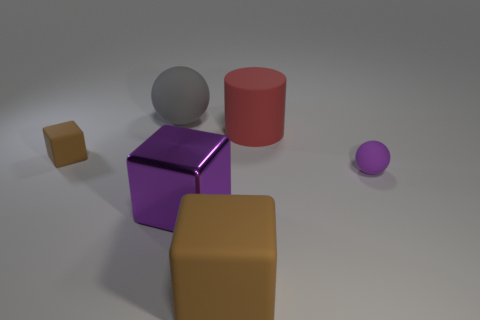Is there any other thing that is made of the same material as the large purple thing?
Keep it short and to the point. No. Is the size of the brown matte block in front of the purple rubber thing the same as the tiny purple rubber object?
Your answer should be very brief. No. Is the number of large matte cubes less than the number of tiny purple metallic cylinders?
Offer a very short reply. No. The tiny object that is in front of the brown thing that is to the left of the rubber sphere left of the red cylinder is what shape?
Give a very brief answer. Sphere. Is there a big purple thing made of the same material as the big brown block?
Your answer should be very brief. No. Does the rubber ball on the right side of the red rubber cylinder have the same color as the metallic cube that is on the right side of the gray matte thing?
Ensure brevity in your answer.  Yes. Is the number of large gray matte objects that are in front of the gray ball less than the number of matte objects?
Your answer should be very brief. Yes. How many objects are either red matte blocks or brown cubes that are to the left of the large matte cube?
Offer a very short reply. 1. What color is the tiny sphere that is the same material as the tiny cube?
Offer a terse response. Purple. How many things are tiny purple metal cylinders or big red matte cylinders?
Your response must be concise. 1. 